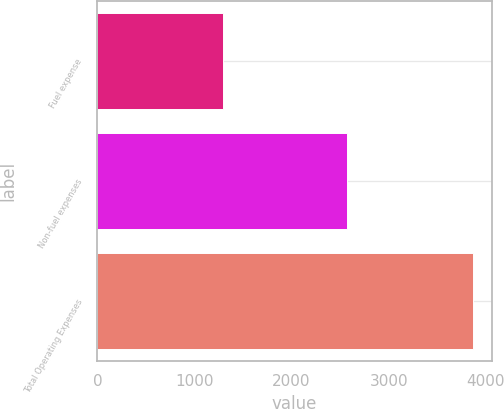<chart> <loc_0><loc_0><loc_500><loc_500><bar_chart><fcel>Fuel expense<fcel>Non-fuel expenses<fcel>Total Operating Expenses<nl><fcel>1297.7<fcel>2571.2<fcel>3868.9<nl></chart> 